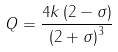Convert formula to latex. <formula><loc_0><loc_0><loc_500><loc_500>Q = \frac { 4 k \left ( 2 - \sigma \right ) } { \left ( 2 + \sigma \right ) ^ { 3 } }</formula> 